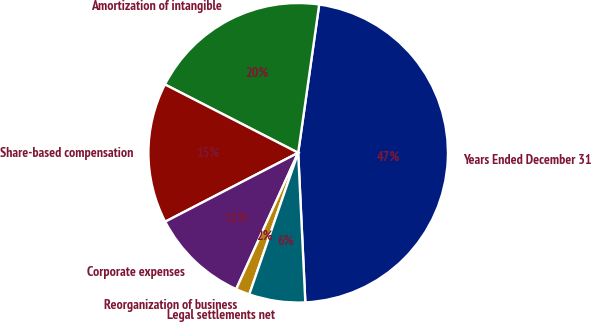<chart> <loc_0><loc_0><loc_500><loc_500><pie_chart><fcel>Years Ended December 31<fcel>Amortization of intangible<fcel>Share-based compensation<fcel>Corporate expenses<fcel>Reorganization of business<fcel>Legal settlements net<nl><fcel>47.0%<fcel>19.7%<fcel>15.15%<fcel>10.6%<fcel>1.5%<fcel>6.05%<nl></chart> 